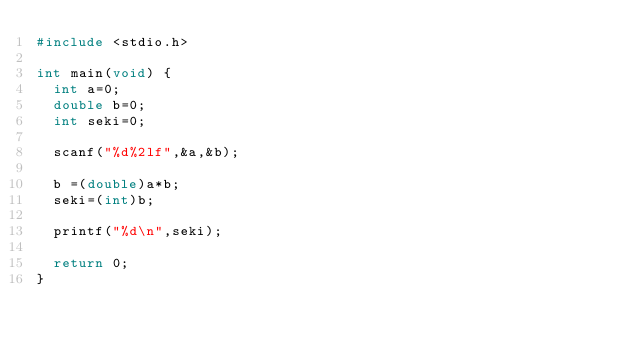<code> <loc_0><loc_0><loc_500><loc_500><_C_>#include <stdio.h>

int main(void) {
  int a=0;
  double b=0;
  int seki=0;

  scanf("%d%2lf",&a,&b);

  b =(double)a*b;
  seki=(int)b;

  printf("%d\n",seki);

  return 0;
}</code> 